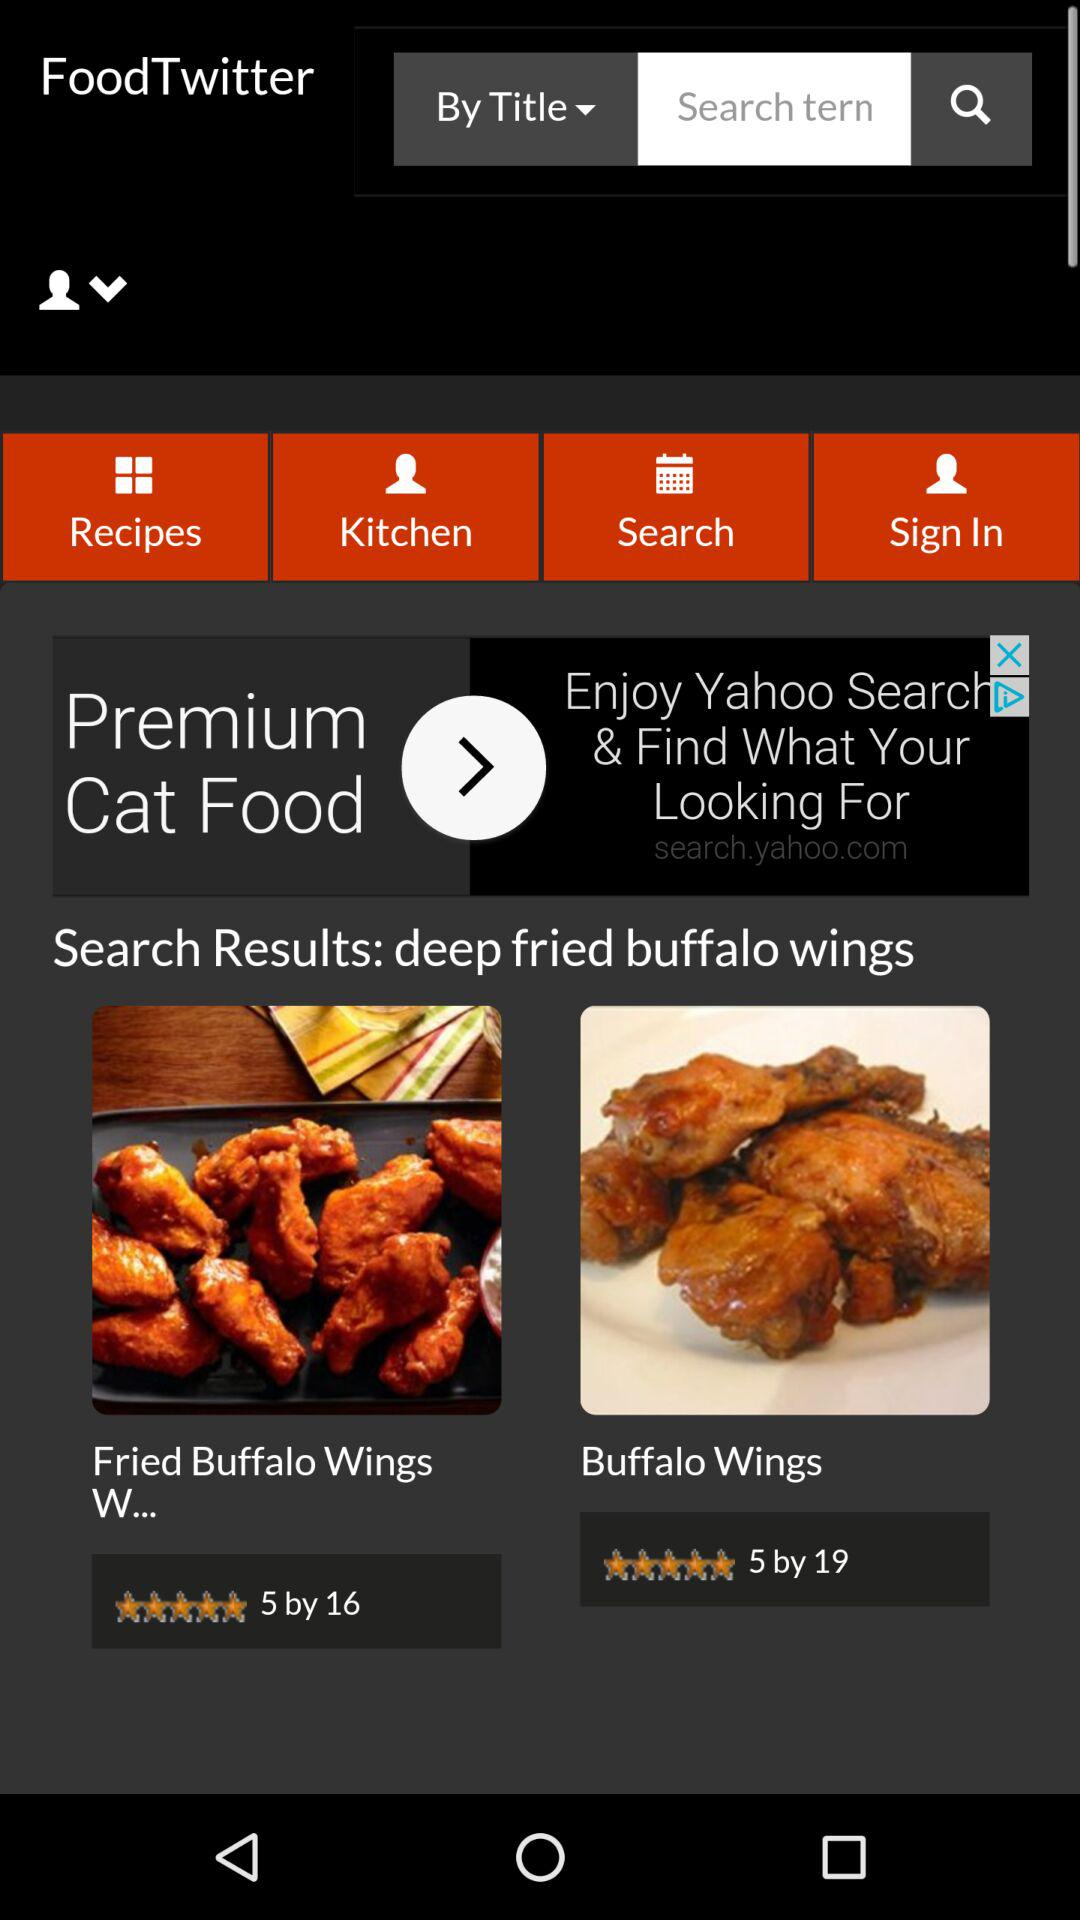What's the rating of "Fried Buffalo Wings W..."? The rating is 5 stars. 